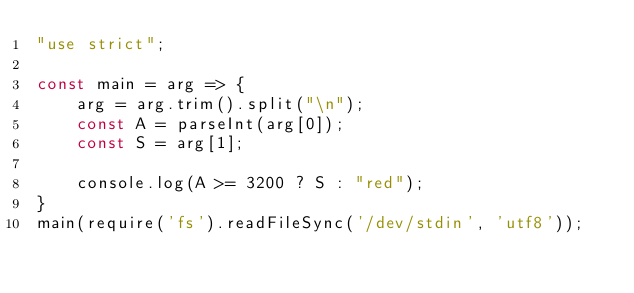Convert code to text. <code><loc_0><loc_0><loc_500><loc_500><_JavaScript_>"use strict";
    
const main = arg => {
    arg = arg.trim().split("\n");
    const A = parseInt(arg[0]);
    const S = arg[1];
    
    console.log(A >= 3200 ? S : "red");
}
main(require('fs').readFileSync('/dev/stdin', 'utf8'));</code> 